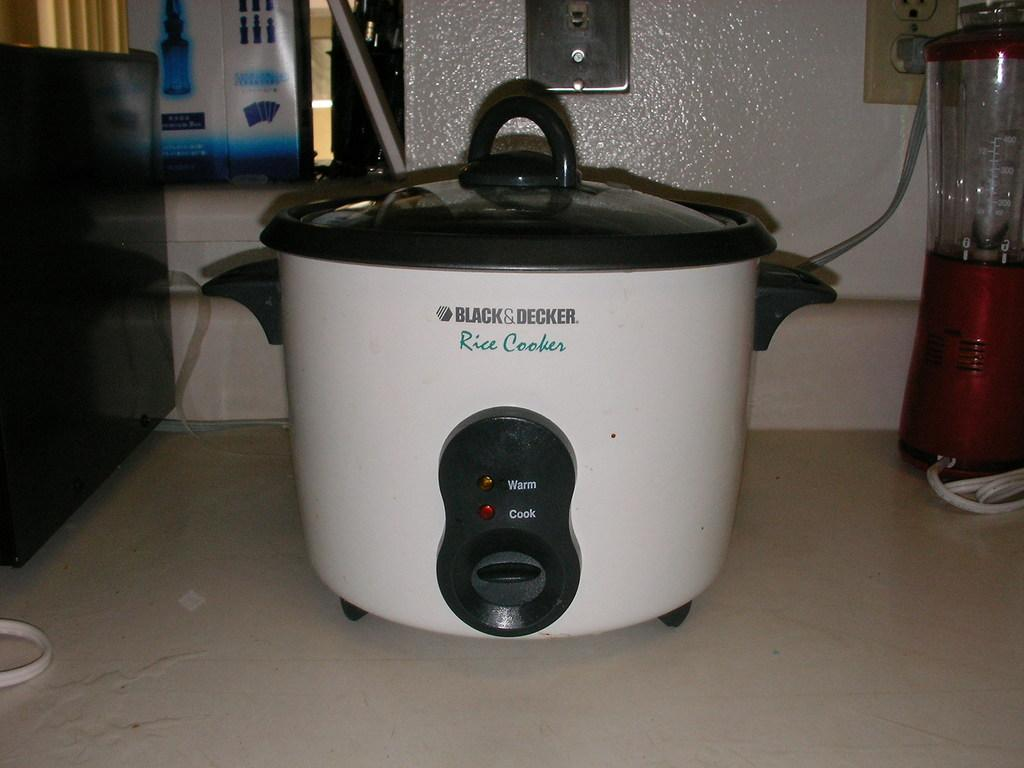<image>
Present a compact description of the photo's key features. A black and decker rice cooker sitting on a counter. 